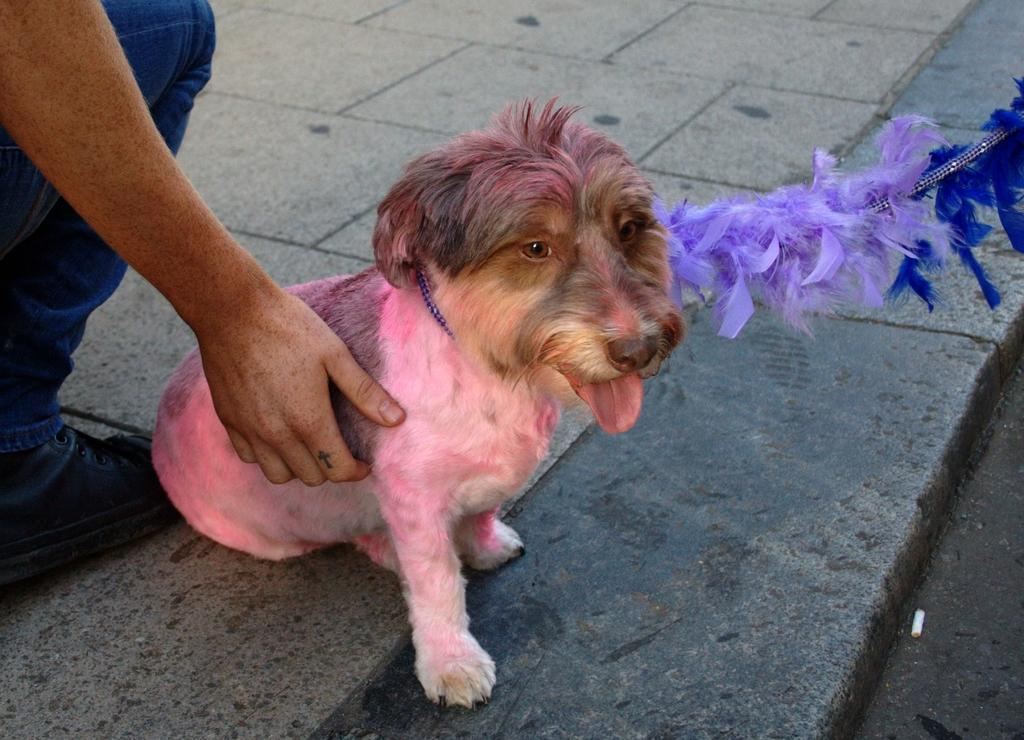Who or what is in the image with the person? The person is placing their hand on a dog. What is the dog doing in the image? The dog is sitting. Is there anything unusual about the dog's appearance in the image? Yes, the dog has a belt connected to a thread. Where are the person and the dog located in the image? They are all on the floor. What type of cow can be seen in the image? There is no cow present in the image; it features a person and a dog. What is the person's hope for the dog in the image? The image does not provide any information about the person's hopes or intentions for the dog. 